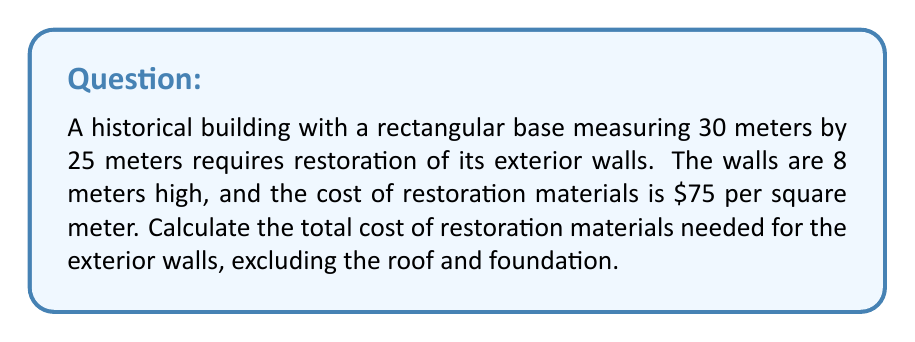Solve this math problem. To solve this problem, we'll follow these steps:

1. Calculate the perimeter of the building:
   $$P = 2(l + w)$$
   $$P = 2(30 + 25) = 2(55) = 110\text{ meters}$$

2. Calculate the total wall area:
   $$A = P \times h$$
   Where $P$ is the perimeter and $h$ is the height
   $$A = 110 \times 8 = 880\text{ square meters}$$

3. Calculate the total cost:
   $$C = A \times \text{cost per square meter}$$
   $$C = 880 \times $75 = $66,000$$

Therefore, the total cost of restoration materials for the exterior walls is $66,000.
Answer: $66,000 